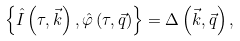Convert formula to latex. <formula><loc_0><loc_0><loc_500><loc_500>\left \{ \hat { I } \left ( \tau , \vec { k } \right ) , \hat { \varphi } \left ( \tau , \vec { q } \right ) \right \} = \Delta \left ( \vec { k } , \vec { q } \right ) ,</formula> 